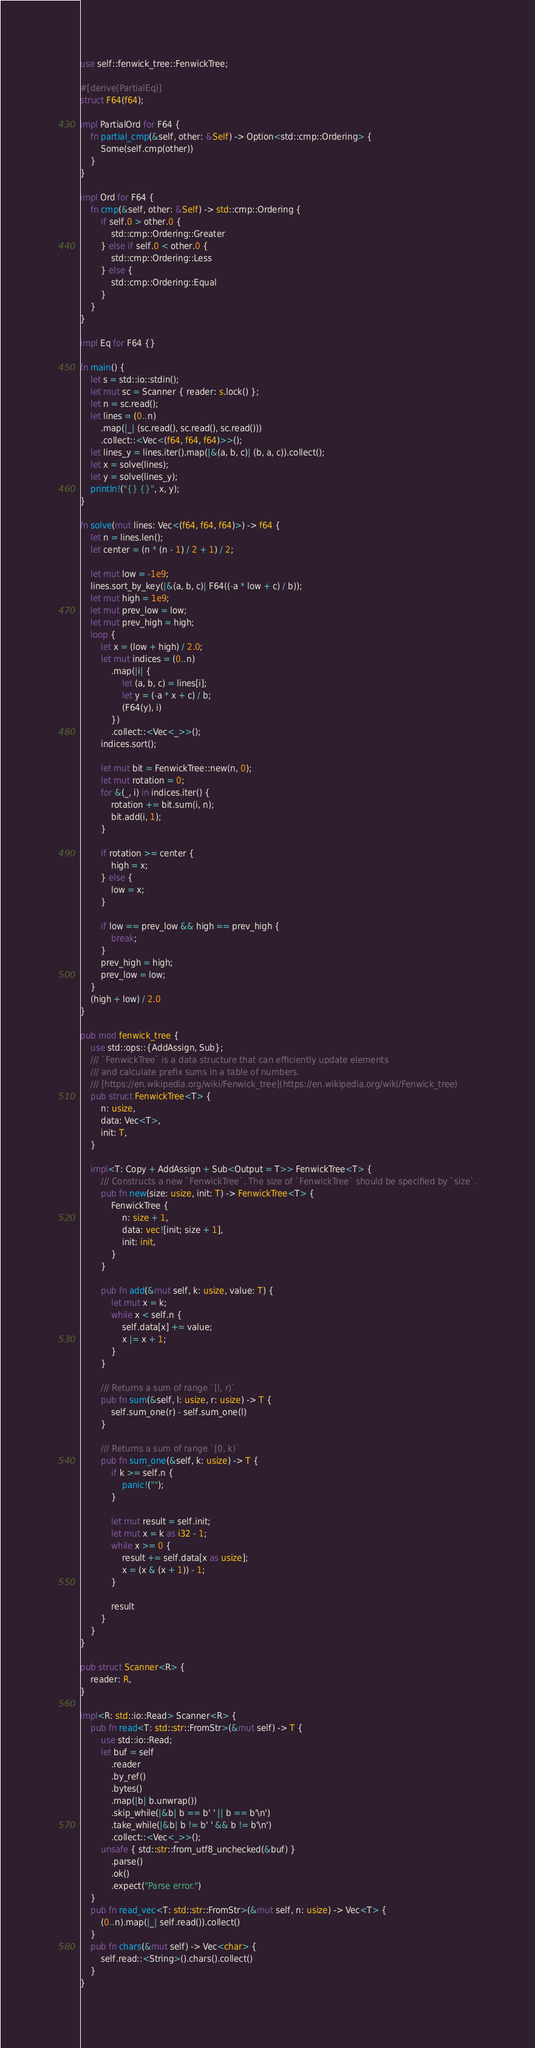<code> <loc_0><loc_0><loc_500><loc_500><_Rust_>use self::fenwick_tree::FenwickTree;

#[derive(PartialEq)]
struct F64(f64);

impl PartialOrd for F64 {
    fn partial_cmp(&self, other: &Self) -> Option<std::cmp::Ordering> {
        Some(self.cmp(other))
    }
}

impl Ord for F64 {
    fn cmp(&self, other: &Self) -> std::cmp::Ordering {
        if self.0 > other.0 {
            std::cmp::Ordering::Greater
        } else if self.0 < other.0 {
            std::cmp::Ordering::Less
        } else {
            std::cmp::Ordering::Equal
        }
    }
}

impl Eq for F64 {}

fn main() {
    let s = std::io::stdin();
    let mut sc = Scanner { reader: s.lock() };
    let n = sc.read();
    let lines = (0..n)
        .map(|_| (sc.read(), sc.read(), sc.read()))
        .collect::<Vec<(f64, f64, f64)>>();
    let lines_y = lines.iter().map(|&(a, b, c)| (b, a, c)).collect();
    let x = solve(lines);
    let y = solve(lines_y);
    println!("{} {}", x, y);
}

fn solve(mut lines: Vec<(f64, f64, f64)>) -> f64 {
    let n = lines.len();
    let center = (n * (n - 1) / 2 + 1) / 2;

    let mut low = -1e9;
    lines.sort_by_key(|&(a, b, c)| F64((-a * low + c) / b));
    let mut high = 1e9;
    let mut prev_low = low;
    let mut prev_high = high;
    loop {
        let x = (low + high) / 2.0;
        let mut indices = (0..n)
            .map(|i| {
                let (a, b, c) = lines[i];
                let y = (-a * x + c) / b;
                (F64(y), i)
            })
            .collect::<Vec<_>>();
        indices.sort();

        let mut bit = FenwickTree::new(n, 0);
        let mut rotation = 0;
        for &(_, i) in indices.iter() {
            rotation += bit.sum(i, n);
            bit.add(i, 1);
        }

        if rotation >= center {
            high = x;
        } else {
            low = x;
        }

        if low == prev_low && high == prev_high {
            break;
        }
        prev_high = high;
        prev_low = low;
    }
    (high + low) / 2.0
}

pub mod fenwick_tree {
    use std::ops::{AddAssign, Sub};
    /// `FenwickTree` is a data structure that can efficiently update elements
    /// and calculate prefix sums in a table of numbers.
    /// [https://en.wikipedia.org/wiki/Fenwick_tree](https://en.wikipedia.org/wiki/Fenwick_tree)
    pub struct FenwickTree<T> {
        n: usize,
        data: Vec<T>,
        init: T,
    }

    impl<T: Copy + AddAssign + Sub<Output = T>> FenwickTree<T> {
        /// Constructs a new `FenwickTree`. The size of `FenwickTree` should be specified by `size`.
        pub fn new(size: usize, init: T) -> FenwickTree<T> {
            FenwickTree {
                n: size + 1,
                data: vec![init; size + 1],
                init: init,
            }
        }

        pub fn add(&mut self, k: usize, value: T) {
            let mut x = k;
            while x < self.n {
                self.data[x] += value;
                x |= x + 1;
            }
        }

        /// Returns a sum of range `[l, r)`
        pub fn sum(&self, l: usize, r: usize) -> T {
            self.sum_one(r) - self.sum_one(l)
        }

        /// Returns a sum of range `[0, k)`
        pub fn sum_one(&self, k: usize) -> T {
            if k >= self.n {
                panic!("");
            }

            let mut result = self.init;
            let mut x = k as i32 - 1;
            while x >= 0 {
                result += self.data[x as usize];
                x = (x & (x + 1)) - 1;
            }

            result
        }
    }
}

pub struct Scanner<R> {
    reader: R,
}

impl<R: std::io::Read> Scanner<R> {
    pub fn read<T: std::str::FromStr>(&mut self) -> T {
        use std::io::Read;
        let buf = self
            .reader
            .by_ref()
            .bytes()
            .map(|b| b.unwrap())
            .skip_while(|&b| b == b' ' || b == b'\n')
            .take_while(|&b| b != b' ' && b != b'\n')
            .collect::<Vec<_>>();
        unsafe { std::str::from_utf8_unchecked(&buf) }
            .parse()
            .ok()
            .expect("Parse error.")
    }
    pub fn read_vec<T: std::str::FromStr>(&mut self, n: usize) -> Vec<T> {
        (0..n).map(|_| self.read()).collect()
    }
    pub fn chars(&mut self) -> Vec<char> {
        self.read::<String>().chars().collect()
    }
}
</code> 